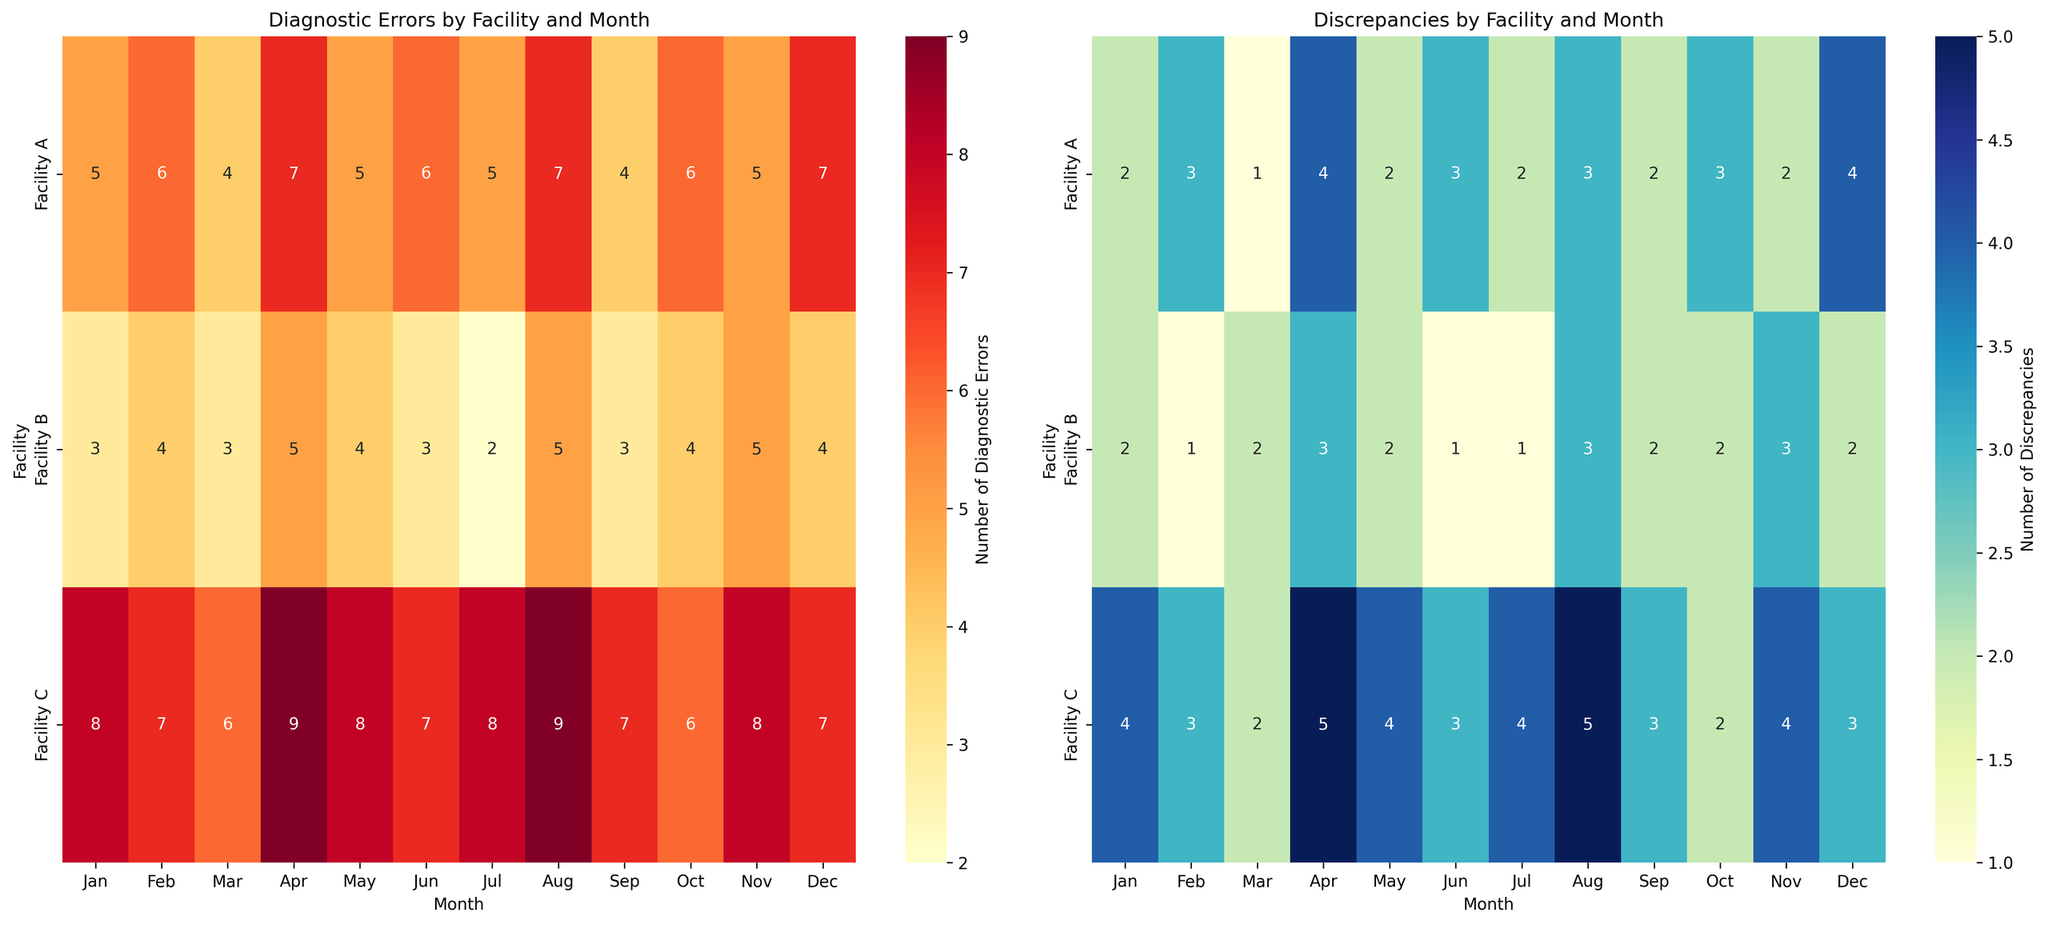What is the total number of diagnostic errors reported by Facility A in the second half of the year? To find the total number of diagnostic errors reported by Facility A in the second half of the year, sum the numbers from July to December: 5 (Jul) + 7 (Aug) + 4 (Sep) + 6 (Oct) + 5 (Nov) + 7 (Dec). The total is 34
Answer: 34 Which facility has the highest average discrepancies reported per month? Calculate the average discrepancies per month for each facility and compare them. For Facility A: (2+3+1+4+2+3+2+3+2+3+2+4)/12 = 2.5. For Facility B: (2+1+2+3+2+1+1+3+2+2+3+2)/12 = 2. To Facility C: (4+3+2+5+4+3+4+5+3+2+4+3)/12 = 3.67
Answer: Facility C Which month shows the maximum discrepancy for Facility B? Look for the highest value in the Discrepancies heatmap for Facility B. The highest value is 3, occurring in April, August, and November
Answer: April, August, November How many discrepancies were reported by Facility C in the first quarter of the year? Sum the discrepancies reported by Facility C in January, February, and March: 4 (Jan) + 3 (Feb) + 2 (Mar). The total is 9
Answer: 9 What is the difference in diagnostic errors between Facility A and Facility C in May? Subtract the number of diagnostic errors for Facility A from Facility C in May: 8 (Facility C) - 5 (Facility A) = 3
Answer: 3 Which facility had the lowest number of discrepancies in any month across the year, and in which month(s)? Identify the lowest value in the Discrepancies heatmap and the facility and month it occurred. The lowest value is 1, occurring in February and June for Facility B
Answer: Facility B, February, June In which month did Facility A report the highest number of diagnostic errors, and how many were reported? Find the highest number in the Diagnostic Errors heatmap for Facility A. The highest value is 7, occurring in April, August, and December
Answer: April, August, December, 7 During August, which facility reported the most diagnostic errors, and how many? Identify the maximum number of diagnostic errors in August from the Diagnostic Errors heatmap. Facility C reported 9 errors
Answer: Facility C, 9 